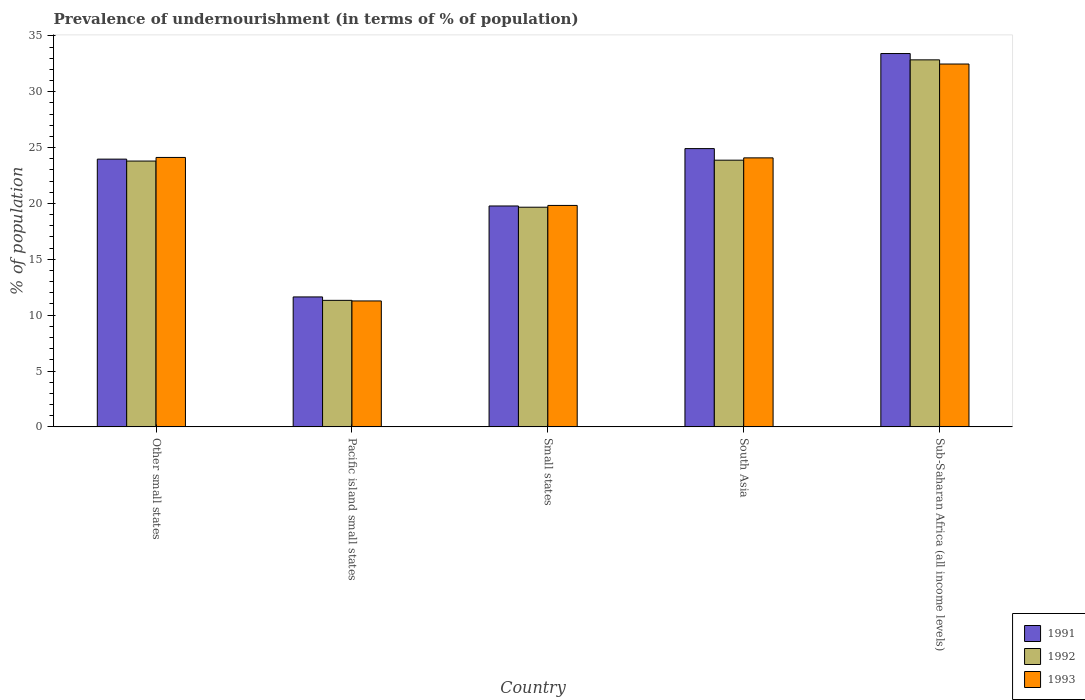How many groups of bars are there?
Make the answer very short. 5. Are the number of bars per tick equal to the number of legend labels?
Ensure brevity in your answer.  Yes. Are the number of bars on each tick of the X-axis equal?
Ensure brevity in your answer.  Yes. How many bars are there on the 2nd tick from the left?
Make the answer very short. 3. What is the label of the 2nd group of bars from the left?
Your answer should be compact. Pacific island small states. What is the percentage of undernourished population in 1991 in Small states?
Provide a short and direct response. 19.77. Across all countries, what is the maximum percentage of undernourished population in 1993?
Make the answer very short. 32.48. Across all countries, what is the minimum percentage of undernourished population in 1992?
Provide a succinct answer. 11.33. In which country was the percentage of undernourished population in 1993 maximum?
Your answer should be compact. Sub-Saharan Africa (all income levels). In which country was the percentage of undernourished population in 1991 minimum?
Offer a very short reply. Pacific island small states. What is the total percentage of undernourished population in 1991 in the graph?
Your response must be concise. 113.71. What is the difference between the percentage of undernourished population in 1992 in Small states and that in South Asia?
Your answer should be very brief. -4.21. What is the difference between the percentage of undernourished population in 1992 in Pacific island small states and the percentage of undernourished population in 1991 in Other small states?
Your answer should be compact. -12.64. What is the average percentage of undernourished population in 1991 per country?
Make the answer very short. 22.74. What is the difference between the percentage of undernourished population of/in 1993 and percentage of undernourished population of/in 1992 in Small states?
Ensure brevity in your answer.  0.16. In how many countries, is the percentage of undernourished population in 1991 greater than 19 %?
Ensure brevity in your answer.  4. What is the ratio of the percentage of undernourished population in 1993 in Other small states to that in South Asia?
Give a very brief answer. 1. What is the difference between the highest and the second highest percentage of undernourished population in 1992?
Offer a terse response. 9.06. What is the difference between the highest and the lowest percentage of undernourished population in 1992?
Your answer should be compact. 21.53. What does the 3rd bar from the left in Pacific island small states represents?
Provide a succinct answer. 1993. What does the 2nd bar from the right in South Asia represents?
Your answer should be very brief. 1992. How many bars are there?
Your answer should be compact. 15. How many countries are there in the graph?
Ensure brevity in your answer.  5. What is the difference between two consecutive major ticks on the Y-axis?
Offer a terse response. 5. How many legend labels are there?
Ensure brevity in your answer.  3. How are the legend labels stacked?
Make the answer very short. Vertical. What is the title of the graph?
Your answer should be very brief. Prevalence of undernourishment (in terms of % of population). Does "2006" appear as one of the legend labels in the graph?
Your response must be concise. No. What is the label or title of the Y-axis?
Give a very brief answer. % of population. What is the % of population of 1991 in Other small states?
Your answer should be very brief. 23.97. What is the % of population in 1992 in Other small states?
Provide a short and direct response. 23.8. What is the % of population in 1993 in Other small states?
Your response must be concise. 24.12. What is the % of population of 1991 in Pacific island small states?
Your answer should be compact. 11.63. What is the % of population of 1992 in Pacific island small states?
Offer a very short reply. 11.33. What is the % of population of 1993 in Pacific island small states?
Provide a succinct answer. 11.27. What is the % of population in 1991 in Small states?
Your response must be concise. 19.77. What is the % of population in 1992 in Small states?
Your answer should be very brief. 19.66. What is the % of population of 1993 in Small states?
Offer a very short reply. 19.82. What is the % of population of 1991 in South Asia?
Your answer should be very brief. 24.91. What is the % of population of 1992 in South Asia?
Make the answer very short. 23.88. What is the % of population of 1993 in South Asia?
Offer a terse response. 24.08. What is the % of population of 1991 in Sub-Saharan Africa (all income levels)?
Keep it short and to the point. 33.42. What is the % of population of 1992 in Sub-Saharan Africa (all income levels)?
Offer a terse response. 32.86. What is the % of population in 1993 in Sub-Saharan Africa (all income levels)?
Give a very brief answer. 32.48. Across all countries, what is the maximum % of population in 1991?
Provide a succinct answer. 33.42. Across all countries, what is the maximum % of population in 1992?
Give a very brief answer. 32.86. Across all countries, what is the maximum % of population of 1993?
Ensure brevity in your answer.  32.48. Across all countries, what is the minimum % of population in 1991?
Make the answer very short. 11.63. Across all countries, what is the minimum % of population of 1992?
Offer a terse response. 11.33. Across all countries, what is the minimum % of population in 1993?
Give a very brief answer. 11.27. What is the total % of population of 1991 in the graph?
Your answer should be very brief. 113.71. What is the total % of population of 1992 in the graph?
Your answer should be very brief. 111.52. What is the total % of population of 1993 in the graph?
Your answer should be very brief. 111.78. What is the difference between the % of population in 1991 in Other small states and that in Pacific island small states?
Offer a very short reply. 12.34. What is the difference between the % of population of 1992 in Other small states and that in Pacific island small states?
Ensure brevity in your answer.  12.47. What is the difference between the % of population of 1993 in Other small states and that in Pacific island small states?
Your answer should be very brief. 12.85. What is the difference between the % of population of 1991 in Other small states and that in Small states?
Keep it short and to the point. 4.19. What is the difference between the % of population in 1992 in Other small states and that in Small states?
Your answer should be compact. 4.13. What is the difference between the % of population of 1993 in Other small states and that in Small states?
Offer a terse response. 4.3. What is the difference between the % of population in 1991 in Other small states and that in South Asia?
Ensure brevity in your answer.  -0.94. What is the difference between the % of population of 1992 in Other small states and that in South Asia?
Your answer should be compact. -0.08. What is the difference between the % of population of 1993 in Other small states and that in South Asia?
Provide a succinct answer. 0.04. What is the difference between the % of population of 1991 in Other small states and that in Sub-Saharan Africa (all income levels)?
Your answer should be very brief. -9.45. What is the difference between the % of population in 1992 in Other small states and that in Sub-Saharan Africa (all income levels)?
Ensure brevity in your answer.  -9.06. What is the difference between the % of population in 1993 in Other small states and that in Sub-Saharan Africa (all income levels)?
Offer a very short reply. -8.36. What is the difference between the % of population of 1991 in Pacific island small states and that in Small states?
Your answer should be very brief. -8.14. What is the difference between the % of population of 1992 in Pacific island small states and that in Small states?
Provide a short and direct response. -8.34. What is the difference between the % of population of 1993 in Pacific island small states and that in Small states?
Offer a terse response. -8.55. What is the difference between the % of population in 1991 in Pacific island small states and that in South Asia?
Make the answer very short. -13.28. What is the difference between the % of population in 1992 in Pacific island small states and that in South Asia?
Ensure brevity in your answer.  -12.55. What is the difference between the % of population in 1993 in Pacific island small states and that in South Asia?
Your answer should be compact. -12.81. What is the difference between the % of population in 1991 in Pacific island small states and that in Sub-Saharan Africa (all income levels)?
Your answer should be very brief. -21.79. What is the difference between the % of population of 1992 in Pacific island small states and that in Sub-Saharan Africa (all income levels)?
Provide a succinct answer. -21.53. What is the difference between the % of population in 1993 in Pacific island small states and that in Sub-Saharan Africa (all income levels)?
Make the answer very short. -21.21. What is the difference between the % of population of 1991 in Small states and that in South Asia?
Provide a short and direct response. -5.14. What is the difference between the % of population in 1992 in Small states and that in South Asia?
Your answer should be very brief. -4.21. What is the difference between the % of population of 1993 in Small states and that in South Asia?
Ensure brevity in your answer.  -4.26. What is the difference between the % of population in 1991 in Small states and that in Sub-Saharan Africa (all income levels)?
Your response must be concise. -13.65. What is the difference between the % of population of 1992 in Small states and that in Sub-Saharan Africa (all income levels)?
Your answer should be very brief. -13.19. What is the difference between the % of population in 1993 in Small states and that in Sub-Saharan Africa (all income levels)?
Your response must be concise. -12.66. What is the difference between the % of population in 1991 in South Asia and that in Sub-Saharan Africa (all income levels)?
Your answer should be very brief. -8.51. What is the difference between the % of population of 1992 in South Asia and that in Sub-Saharan Africa (all income levels)?
Provide a succinct answer. -8.98. What is the difference between the % of population of 1993 in South Asia and that in Sub-Saharan Africa (all income levels)?
Provide a succinct answer. -8.4. What is the difference between the % of population of 1991 in Other small states and the % of population of 1992 in Pacific island small states?
Your response must be concise. 12.64. What is the difference between the % of population of 1991 in Other small states and the % of population of 1993 in Pacific island small states?
Your response must be concise. 12.69. What is the difference between the % of population in 1992 in Other small states and the % of population in 1993 in Pacific island small states?
Your answer should be very brief. 12.52. What is the difference between the % of population in 1991 in Other small states and the % of population in 1992 in Small states?
Give a very brief answer. 4.3. What is the difference between the % of population in 1991 in Other small states and the % of population in 1993 in Small states?
Keep it short and to the point. 4.14. What is the difference between the % of population of 1992 in Other small states and the % of population of 1993 in Small states?
Provide a succinct answer. 3.97. What is the difference between the % of population in 1991 in Other small states and the % of population in 1992 in South Asia?
Provide a short and direct response. 0.09. What is the difference between the % of population in 1991 in Other small states and the % of population in 1993 in South Asia?
Your answer should be compact. -0.11. What is the difference between the % of population in 1992 in Other small states and the % of population in 1993 in South Asia?
Keep it short and to the point. -0.29. What is the difference between the % of population in 1991 in Other small states and the % of population in 1992 in Sub-Saharan Africa (all income levels)?
Your answer should be very brief. -8.89. What is the difference between the % of population in 1991 in Other small states and the % of population in 1993 in Sub-Saharan Africa (all income levels)?
Give a very brief answer. -8.51. What is the difference between the % of population in 1992 in Other small states and the % of population in 1993 in Sub-Saharan Africa (all income levels)?
Your answer should be very brief. -8.69. What is the difference between the % of population in 1991 in Pacific island small states and the % of population in 1992 in Small states?
Give a very brief answer. -8.03. What is the difference between the % of population of 1991 in Pacific island small states and the % of population of 1993 in Small states?
Ensure brevity in your answer.  -8.19. What is the difference between the % of population of 1992 in Pacific island small states and the % of population of 1993 in Small states?
Offer a terse response. -8.5. What is the difference between the % of population in 1991 in Pacific island small states and the % of population in 1992 in South Asia?
Provide a short and direct response. -12.24. What is the difference between the % of population of 1991 in Pacific island small states and the % of population of 1993 in South Asia?
Ensure brevity in your answer.  -12.45. What is the difference between the % of population in 1992 in Pacific island small states and the % of population in 1993 in South Asia?
Your answer should be compact. -12.76. What is the difference between the % of population in 1991 in Pacific island small states and the % of population in 1992 in Sub-Saharan Africa (all income levels)?
Offer a very short reply. -21.22. What is the difference between the % of population of 1991 in Pacific island small states and the % of population of 1993 in Sub-Saharan Africa (all income levels)?
Provide a short and direct response. -20.85. What is the difference between the % of population in 1992 in Pacific island small states and the % of population in 1993 in Sub-Saharan Africa (all income levels)?
Make the answer very short. -21.16. What is the difference between the % of population in 1991 in Small states and the % of population in 1992 in South Asia?
Your response must be concise. -4.1. What is the difference between the % of population in 1991 in Small states and the % of population in 1993 in South Asia?
Ensure brevity in your answer.  -4.31. What is the difference between the % of population of 1992 in Small states and the % of population of 1993 in South Asia?
Provide a short and direct response. -4.42. What is the difference between the % of population of 1991 in Small states and the % of population of 1992 in Sub-Saharan Africa (all income levels)?
Ensure brevity in your answer.  -13.08. What is the difference between the % of population of 1991 in Small states and the % of population of 1993 in Sub-Saharan Africa (all income levels)?
Your answer should be very brief. -12.71. What is the difference between the % of population in 1992 in Small states and the % of population in 1993 in Sub-Saharan Africa (all income levels)?
Your answer should be very brief. -12.82. What is the difference between the % of population in 1991 in South Asia and the % of population in 1992 in Sub-Saharan Africa (all income levels)?
Your answer should be compact. -7.95. What is the difference between the % of population of 1991 in South Asia and the % of population of 1993 in Sub-Saharan Africa (all income levels)?
Your answer should be very brief. -7.57. What is the difference between the % of population in 1992 in South Asia and the % of population in 1993 in Sub-Saharan Africa (all income levels)?
Offer a terse response. -8.61. What is the average % of population of 1991 per country?
Ensure brevity in your answer.  22.74. What is the average % of population of 1992 per country?
Your answer should be very brief. 22.3. What is the average % of population of 1993 per country?
Your answer should be compact. 22.36. What is the difference between the % of population of 1991 and % of population of 1992 in Other small states?
Ensure brevity in your answer.  0.17. What is the difference between the % of population in 1991 and % of population in 1993 in Other small states?
Your answer should be very brief. -0.15. What is the difference between the % of population in 1992 and % of population in 1993 in Other small states?
Make the answer very short. -0.32. What is the difference between the % of population in 1991 and % of population in 1992 in Pacific island small states?
Your response must be concise. 0.31. What is the difference between the % of population in 1991 and % of population in 1993 in Pacific island small states?
Your answer should be compact. 0.36. What is the difference between the % of population in 1992 and % of population in 1993 in Pacific island small states?
Make the answer very short. 0.05. What is the difference between the % of population of 1991 and % of population of 1992 in Small states?
Keep it short and to the point. 0.11. What is the difference between the % of population in 1991 and % of population in 1993 in Small states?
Make the answer very short. -0.05. What is the difference between the % of population of 1992 and % of population of 1993 in Small states?
Your response must be concise. -0.16. What is the difference between the % of population in 1991 and % of population in 1992 in South Asia?
Make the answer very short. 1.04. What is the difference between the % of population in 1991 and % of population in 1993 in South Asia?
Your answer should be compact. 0.83. What is the difference between the % of population in 1992 and % of population in 1993 in South Asia?
Your response must be concise. -0.21. What is the difference between the % of population in 1991 and % of population in 1992 in Sub-Saharan Africa (all income levels)?
Your response must be concise. 0.57. What is the difference between the % of population in 1991 and % of population in 1993 in Sub-Saharan Africa (all income levels)?
Your answer should be very brief. 0.94. What is the difference between the % of population of 1992 and % of population of 1993 in Sub-Saharan Africa (all income levels)?
Offer a terse response. 0.37. What is the ratio of the % of population in 1991 in Other small states to that in Pacific island small states?
Provide a succinct answer. 2.06. What is the ratio of the % of population in 1992 in Other small states to that in Pacific island small states?
Offer a very short reply. 2.1. What is the ratio of the % of population in 1993 in Other small states to that in Pacific island small states?
Ensure brevity in your answer.  2.14. What is the ratio of the % of population in 1991 in Other small states to that in Small states?
Offer a terse response. 1.21. What is the ratio of the % of population in 1992 in Other small states to that in Small states?
Your response must be concise. 1.21. What is the ratio of the % of population of 1993 in Other small states to that in Small states?
Offer a very short reply. 1.22. What is the ratio of the % of population in 1991 in Other small states to that in South Asia?
Your answer should be very brief. 0.96. What is the ratio of the % of population in 1991 in Other small states to that in Sub-Saharan Africa (all income levels)?
Keep it short and to the point. 0.72. What is the ratio of the % of population of 1992 in Other small states to that in Sub-Saharan Africa (all income levels)?
Offer a very short reply. 0.72. What is the ratio of the % of population of 1993 in Other small states to that in Sub-Saharan Africa (all income levels)?
Your answer should be very brief. 0.74. What is the ratio of the % of population of 1991 in Pacific island small states to that in Small states?
Provide a succinct answer. 0.59. What is the ratio of the % of population in 1992 in Pacific island small states to that in Small states?
Provide a short and direct response. 0.58. What is the ratio of the % of population of 1993 in Pacific island small states to that in Small states?
Provide a succinct answer. 0.57. What is the ratio of the % of population of 1991 in Pacific island small states to that in South Asia?
Provide a short and direct response. 0.47. What is the ratio of the % of population of 1992 in Pacific island small states to that in South Asia?
Make the answer very short. 0.47. What is the ratio of the % of population of 1993 in Pacific island small states to that in South Asia?
Your answer should be very brief. 0.47. What is the ratio of the % of population of 1991 in Pacific island small states to that in Sub-Saharan Africa (all income levels)?
Provide a succinct answer. 0.35. What is the ratio of the % of population in 1992 in Pacific island small states to that in Sub-Saharan Africa (all income levels)?
Your answer should be compact. 0.34. What is the ratio of the % of population in 1993 in Pacific island small states to that in Sub-Saharan Africa (all income levels)?
Provide a succinct answer. 0.35. What is the ratio of the % of population of 1991 in Small states to that in South Asia?
Ensure brevity in your answer.  0.79. What is the ratio of the % of population in 1992 in Small states to that in South Asia?
Your answer should be very brief. 0.82. What is the ratio of the % of population of 1993 in Small states to that in South Asia?
Keep it short and to the point. 0.82. What is the ratio of the % of population of 1991 in Small states to that in Sub-Saharan Africa (all income levels)?
Keep it short and to the point. 0.59. What is the ratio of the % of population in 1992 in Small states to that in Sub-Saharan Africa (all income levels)?
Provide a short and direct response. 0.6. What is the ratio of the % of population of 1993 in Small states to that in Sub-Saharan Africa (all income levels)?
Your answer should be very brief. 0.61. What is the ratio of the % of population in 1991 in South Asia to that in Sub-Saharan Africa (all income levels)?
Provide a succinct answer. 0.75. What is the ratio of the % of population of 1992 in South Asia to that in Sub-Saharan Africa (all income levels)?
Keep it short and to the point. 0.73. What is the ratio of the % of population in 1993 in South Asia to that in Sub-Saharan Africa (all income levels)?
Provide a succinct answer. 0.74. What is the difference between the highest and the second highest % of population in 1991?
Offer a very short reply. 8.51. What is the difference between the highest and the second highest % of population in 1992?
Keep it short and to the point. 8.98. What is the difference between the highest and the second highest % of population in 1993?
Your response must be concise. 8.36. What is the difference between the highest and the lowest % of population of 1991?
Ensure brevity in your answer.  21.79. What is the difference between the highest and the lowest % of population in 1992?
Your answer should be compact. 21.53. What is the difference between the highest and the lowest % of population of 1993?
Keep it short and to the point. 21.21. 